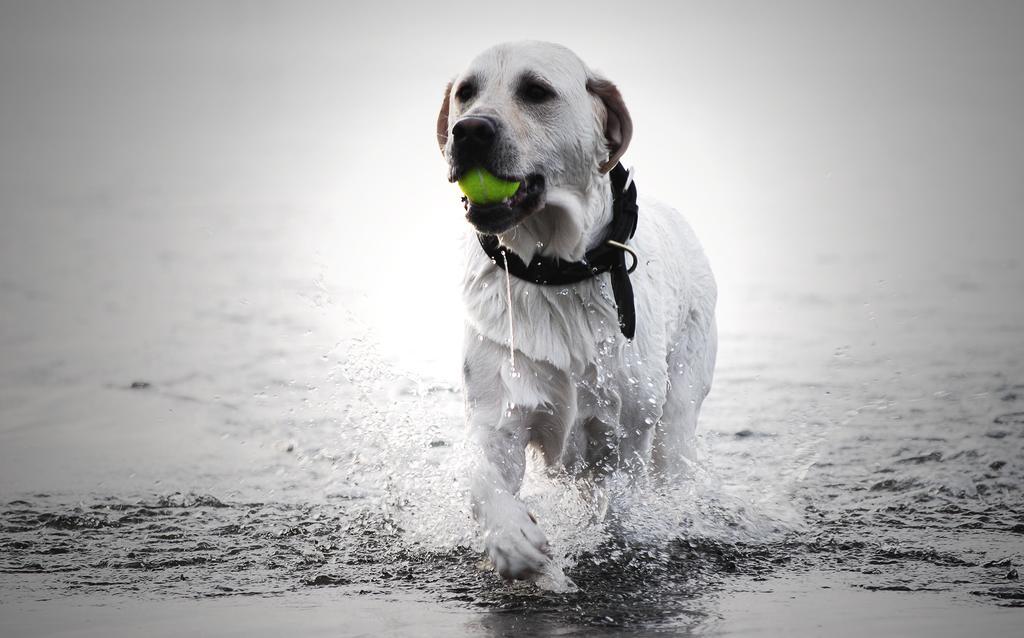Can you describe this image briefly? This is a black and white picture. In the center of the picture there is a dog holding a ball. The dog is in the water. 